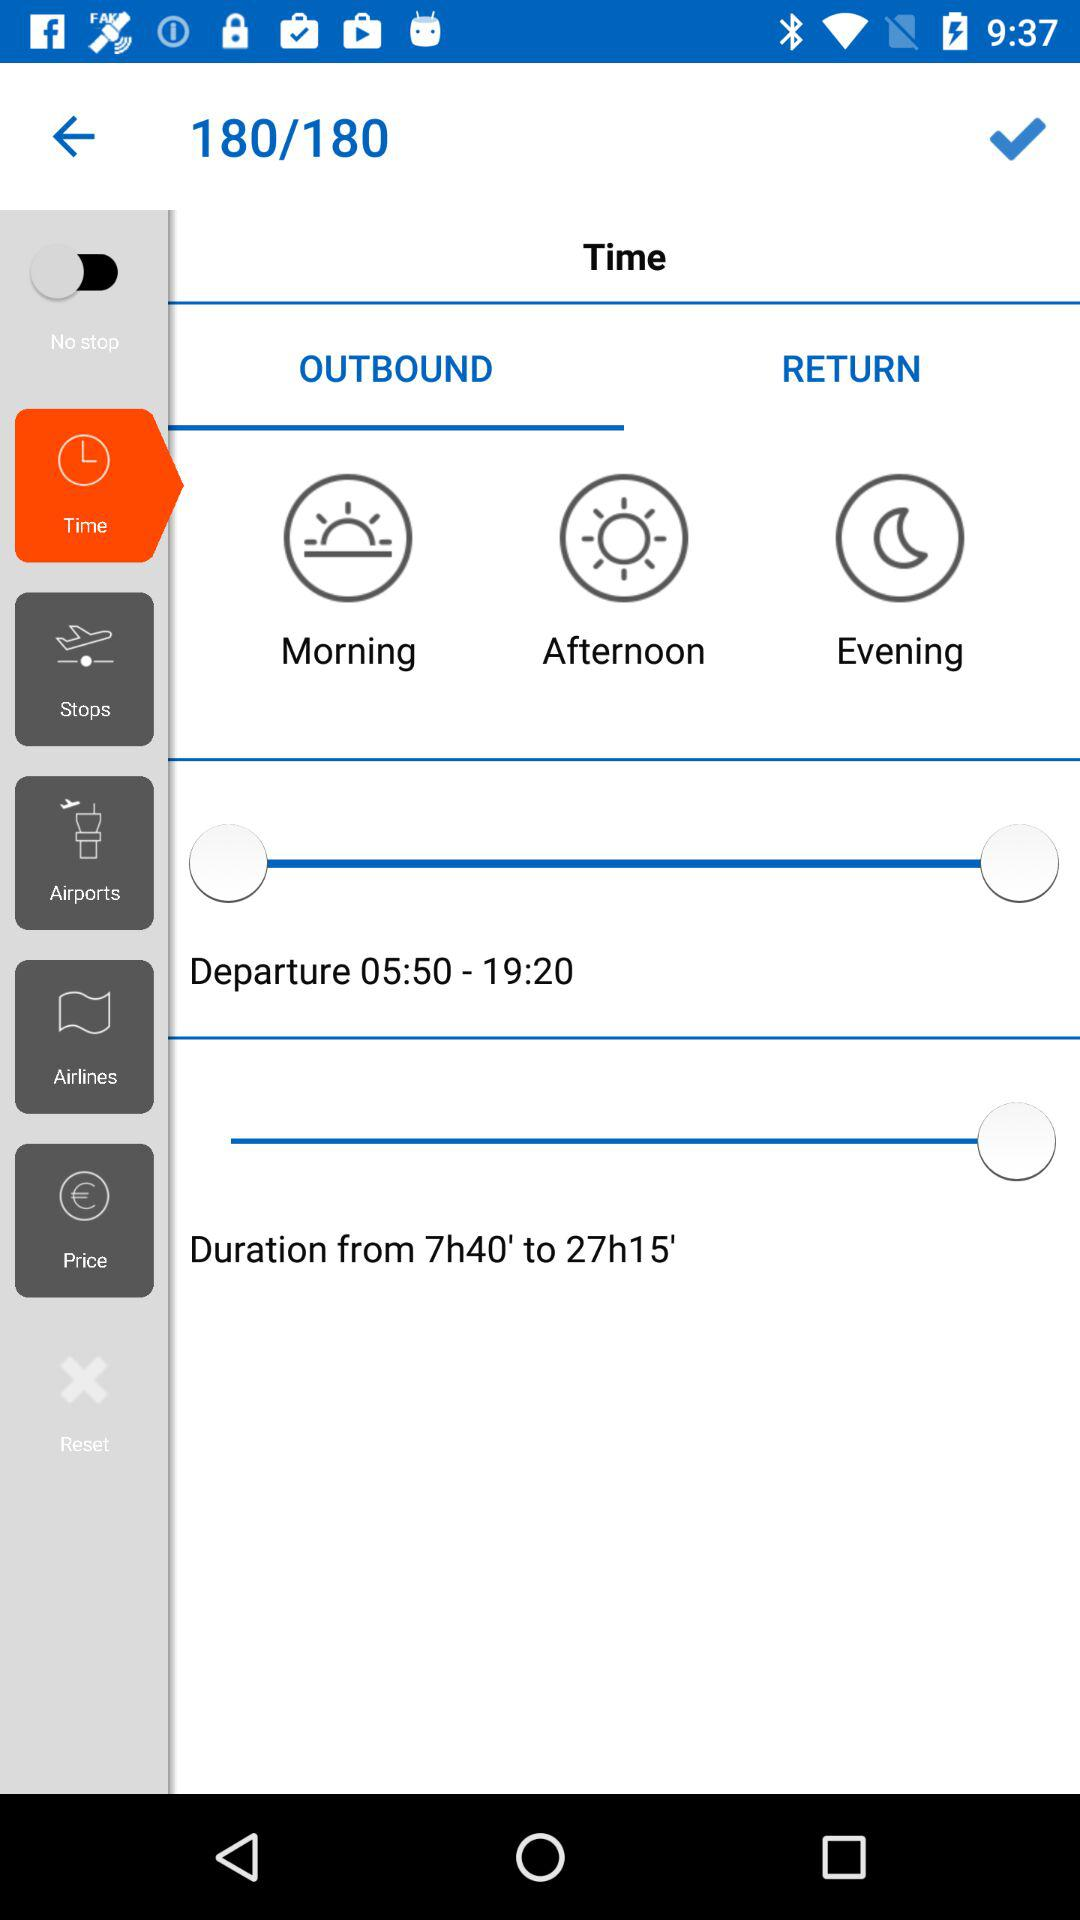Which tab has been selected? The selected tab is "OUTBOUND". 